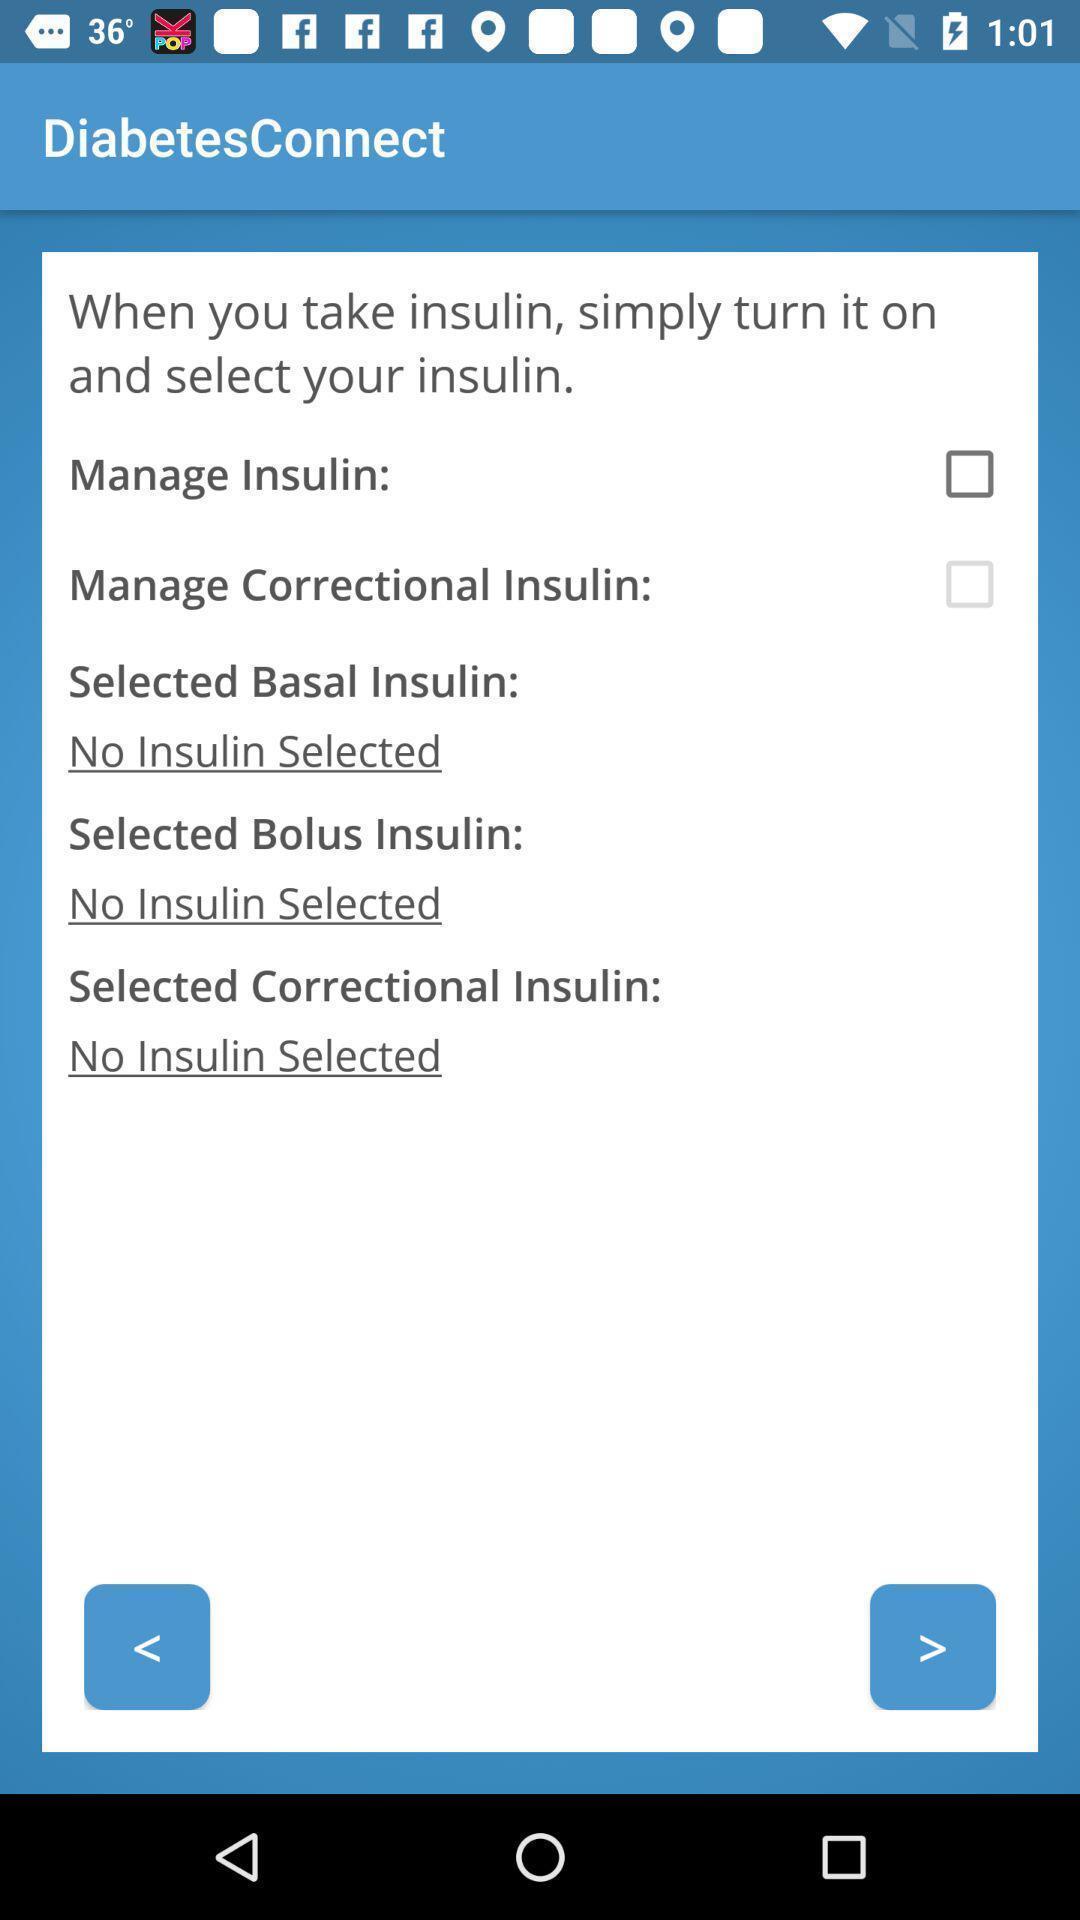Give me a summary of this screen capture. Page that displaying about insulin. 